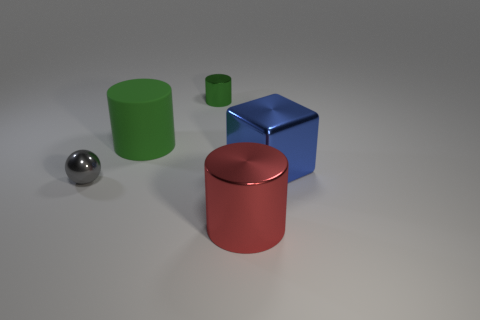There is another cylinder that is the same color as the small cylinder; what size is it?
Give a very brief answer. Large. The large matte object that is the same color as the small cylinder is what shape?
Provide a short and direct response. Cylinder. There is a small thing that is made of the same material as the small sphere; what is its color?
Your answer should be very brief. Green. Are there more green matte things than metal cylinders?
Your answer should be very brief. No. What size is the object that is in front of the blue thing and behind the big shiny cylinder?
Offer a very short reply. Small. What is the material of the big thing that is the same color as the small metallic cylinder?
Your response must be concise. Rubber. Are there the same number of matte objects to the right of the large blue block and small brown cylinders?
Make the answer very short. Yes. Does the gray ball have the same size as the green metal cylinder?
Offer a terse response. Yes. The thing that is both left of the tiny green cylinder and on the right side of the gray shiny sphere is what color?
Offer a very short reply. Green. There is a large cylinder to the left of the small shiny object that is on the right side of the big green cylinder; what is its material?
Offer a terse response. Rubber. 